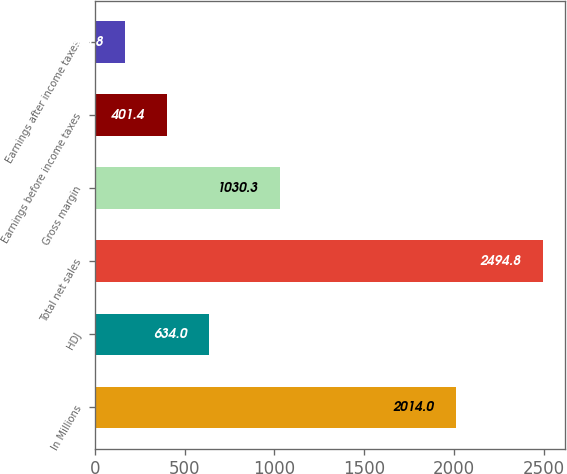Convert chart to OTSL. <chart><loc_0><loc_0><loc_500><loc_500><bar_chart><fcel>In Millions<fcel>HDJ<fcel>Total net sales<fcel>Gross margin<fcel>Earnings before income taxes<fcel>Earnings after income taxes<nl><fcel>2014<fcel>634<fcel>2494.8<fcel>1030.3<fcel>401.4<fcel>168.8<nl></chart> 